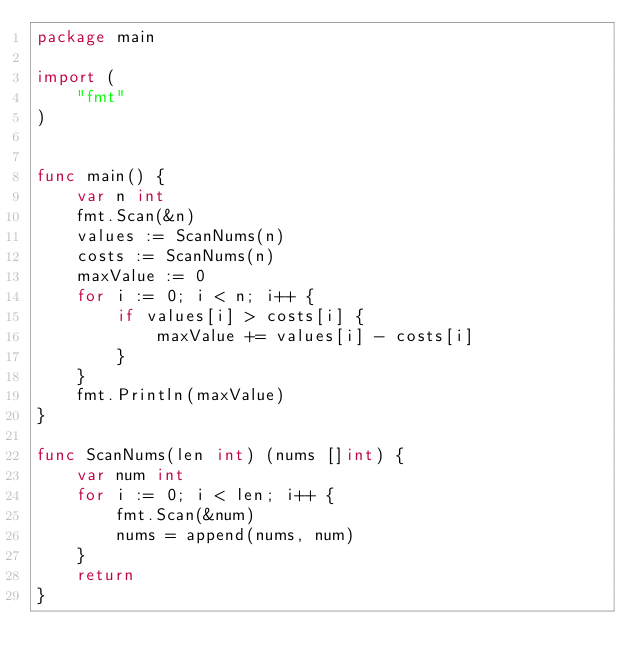Convert code to text. <code><loc_0><loc_0><loc_500><loc_500><_Go_>package main

import (
	"fmt"
)


func main() {
	var n int
	fmt.Scan(&n)
	values := ScanNums(n)
	costs := ScanNums(n)
	maxValue := 0
	for i := 0; i < n; i++ {
		if values[i] > costs[i] {
			maxValue += values[i] - costs[i]
		}
	}
	fmt.Println(maxValue)
}

func ScanNums(len int) (nums []int) {
	var num int
	for i := 0; i < len; i++ {
		fmt.Scan(&num)
		nums = append(nums, num)
	}
	return
}
</code> 